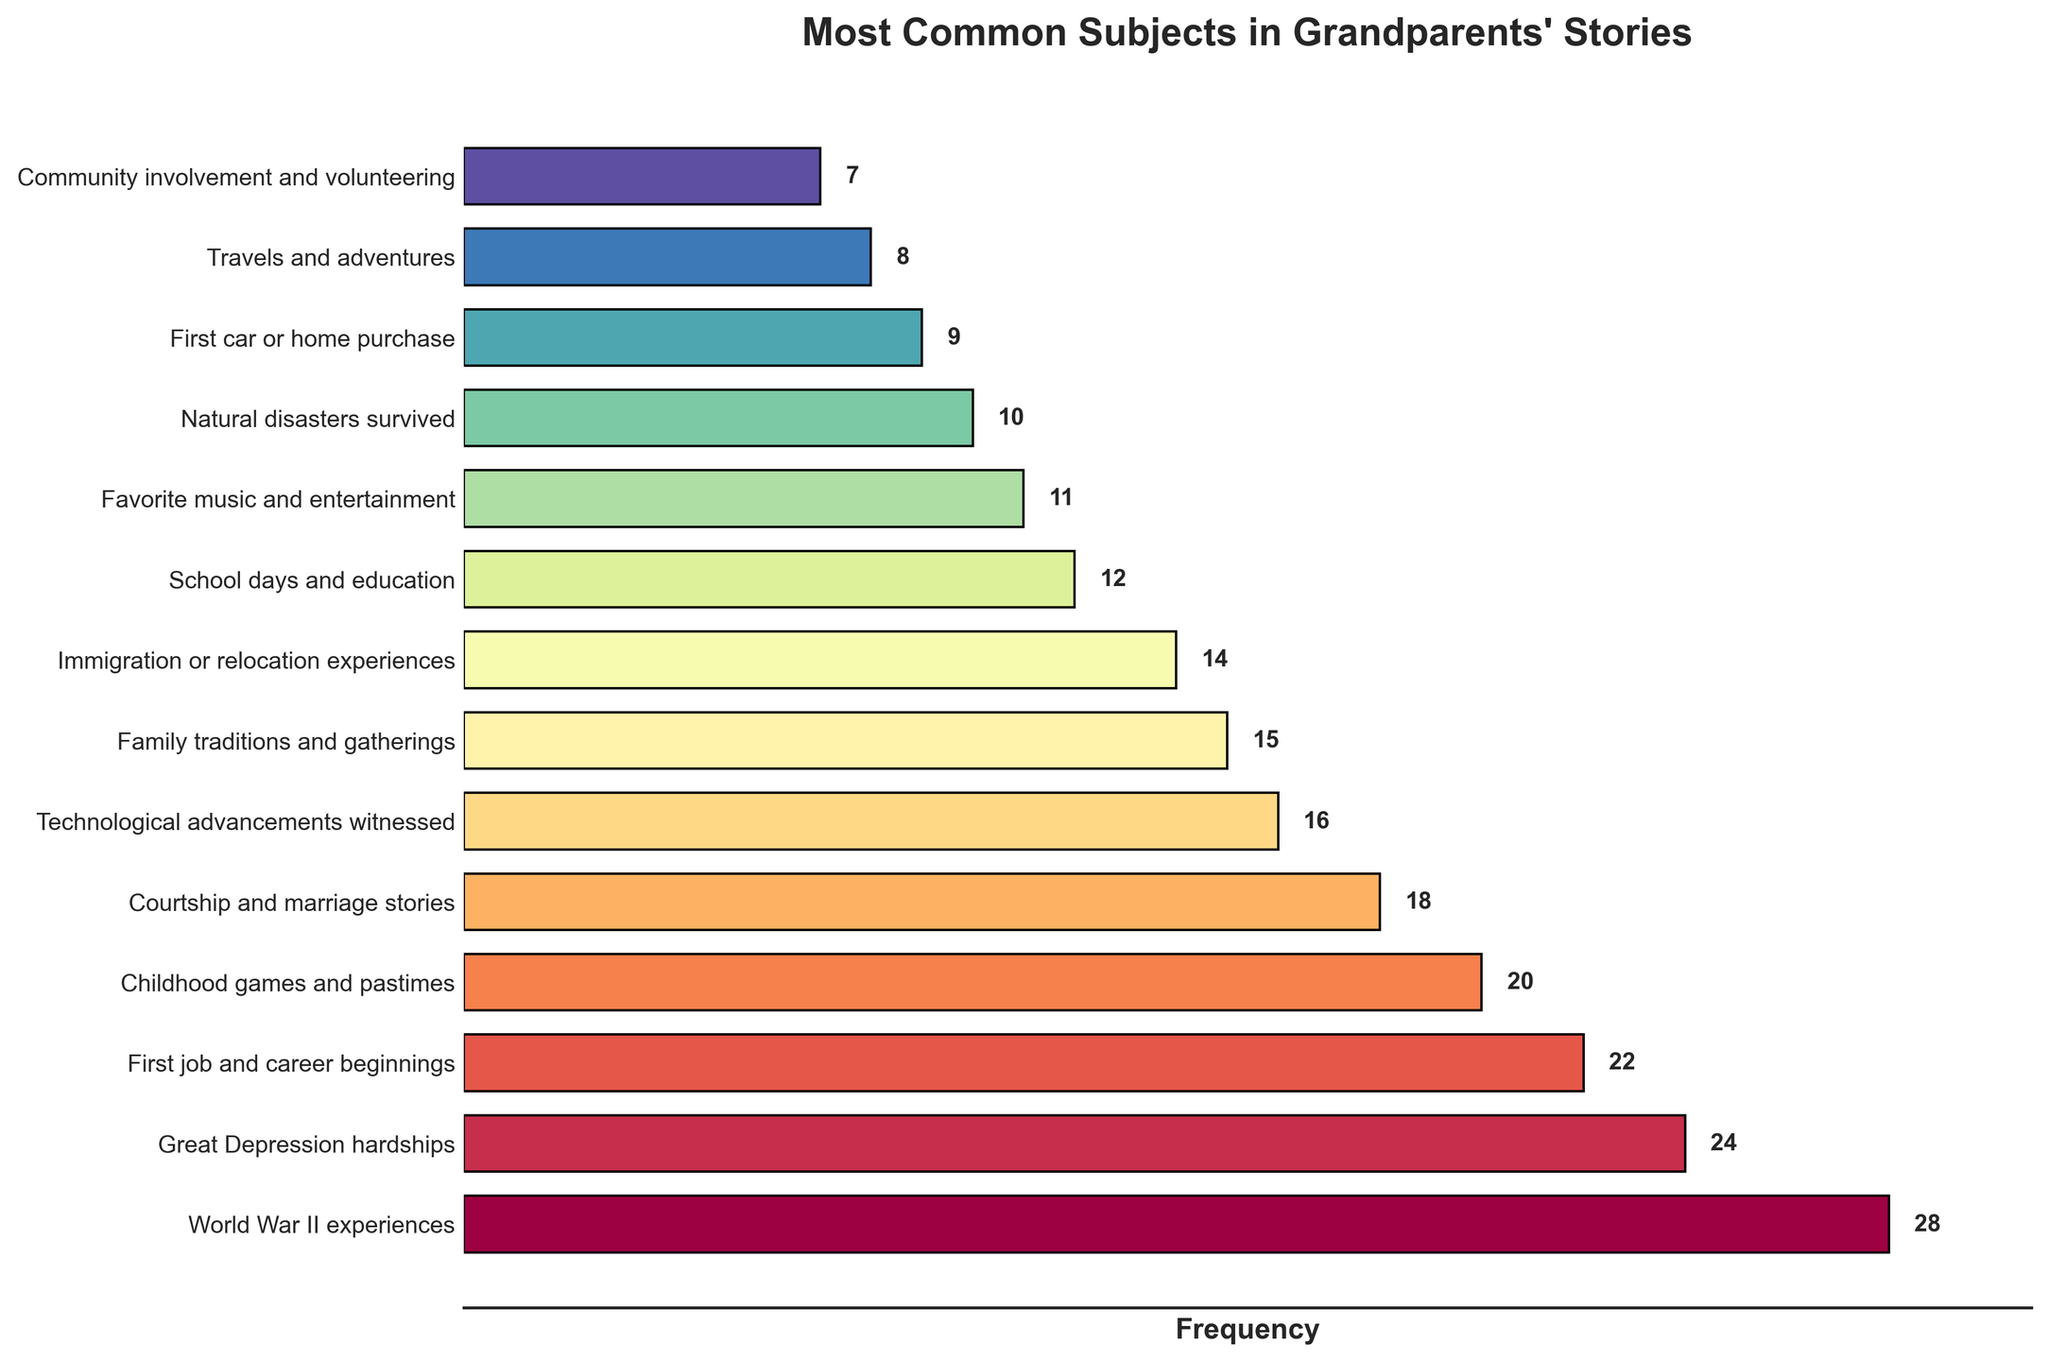What's the most common subject in grandparents' stories? The highest bar represents the most common subject, which we can see is labeled as "World War II experiences" on the y-axis and has the highest frequency value of 28.
Answer: World War II experiences How many more times do grandparents talk about World War II experiences compared to their first car or home purchase? The frequency of World War II experiences is 28, and the frequency of the first car or home purchase is 9. Subtracting these, we get 28 - 9 = 19.
Answer: 19 Which subject has a greater frequency, childhood games and pastimes or courtship and marriage stories? Childhood games and pastimes have a frequency of 20, and courtship and marriage stories have a frequency of 18. Since 20 is greater than 18, childhood games and pastimes have a higher frequency.
Answer: Childhood games and pastimes What is the combined frequency of stories about the Great Depression hardships and technological advancements witnessed? The frequency for the Great Depression hardships is 24, and for technological advancements witnessed is 16. Adding these together, we get 24 + 16 = 40.
Answer: 40 Are there more stories about family traditions and gatherings or Immigration or relocation experiences? Family traditions and gatherings have a frequency of 15, while immigration or relocation experiences have a frequency of 14. Since 15 is greater than 14, there are more stories about family traditions and gatherings.
Answer: Family traditions and gatherings What is the difference in frequency between community involvement and volunteering and natural disasters survived? Community involvement and volunteering have a frequency of 7 and natural disasters survived have a frequency of 10. The difference is 10 - 7 = 3.
Answer: 3 How many stories are about significant life events (combining immigration or relocation experiences, first job and career beginnings, and courtship and marriage stories)? Immigration or relocation experiences have a frequency of 14, first job and career beginnings have 22, and courtship and marriage stories have 18. Adding these together, we get 14 + 22 + 18 = 54.
Answer: 54 What's the average frequency of stories about World War II experiences, Great Depression hardships, and natural disasters survived? The frequencies are 28 (World War II experiences), 24 (Great Depression hardships), and 10 (natural disasters survived). Adding these, we get 28 + 24 + 10 = 62. Dividing by the number of subjects (3), we get 62 / 3 ≈ 20.67.
Answer: 20.67 Which subject has the shortest bar in the plot? The shortest bar visually on the plot corresponds to "Community involvement and volunteering," which has the lowest frequency of 7.
Answer: Community involvement and volunteering 